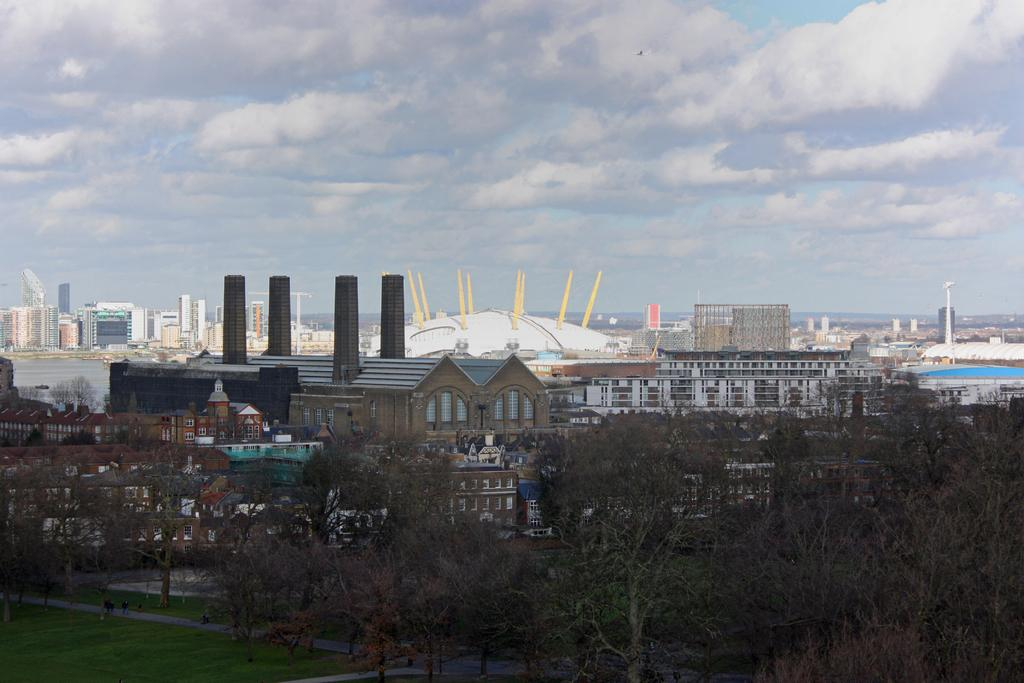What type of structures can be seen in the image? There are buildings in the image. What type of vegetation is present in the image? There are trees and grass visible in the image. What else can be seen in the image besides buildings and vegetation? There are other objects in the image. What is visible in the background of the image? The sky is visible in the background of the image. What type of insurance policy is being discussed in the image? There is no mention of insurance or any discussion in the image. How many books are visible in the image? There are no books present in the image. 